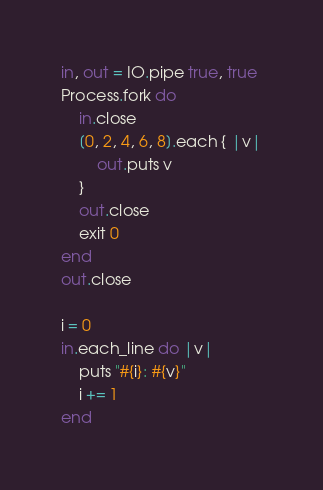Convert code to text. <code><loc_0><loc_0><loc_500><loc_500><_Crystal_>in, out = IO.pipe true, true
Process.fork do
	in.close
	[0, 2, 4, 6, 8].each { |v|
		out.puts v
	}
	out.close
	exit 0
end
out.close

i = 0
in.each_line do |v|
	puts "#{i}: #{v}"
	i += 1
end</code> 